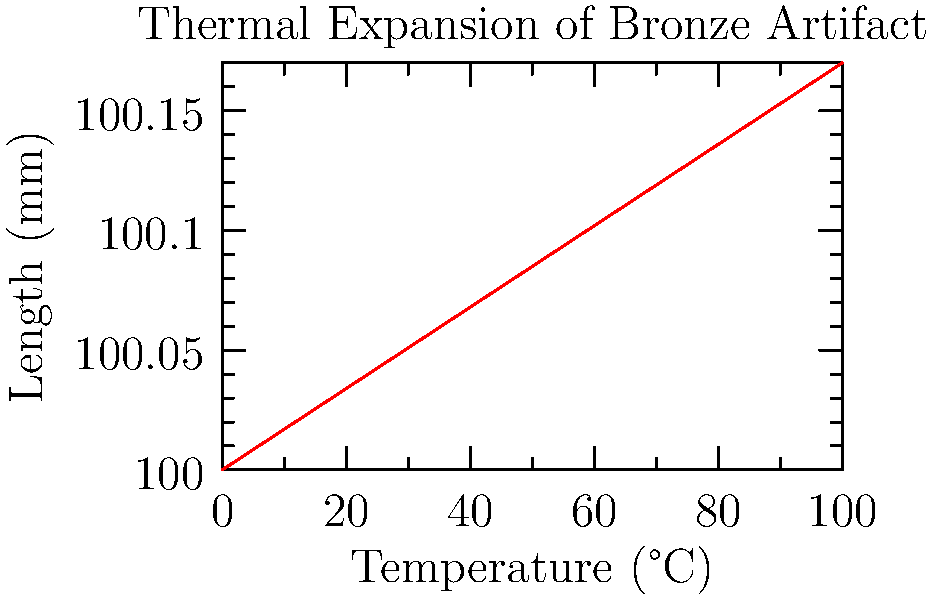A bronze artifact from an ancient civilization is being studied for its thermal expansion properties. The graph shows the length of the artifact as it is exposed to different temperatures. If the artifact's original length at 0°C is 100 mm, what is its coefficient of linear thermal expansion? To find the coefficient of linear thermal expansion (α), we'll use the formula:

$$ \Delta L = L_0 \alpha \Delta T $$

Where:
$\Delta L$ = Change in length
$L_0$ = Original length
$\alpha$ = Coefficient of linear thermal expansion
$\Delta T$ = Change in temperature

Steps:
1. Find $\Delta L$: At 100°C, L = 100.170 mm, so $\Delta L = 100.170 - 100.000 = 0.170$ mm

2. We know:
   $L_0 = 100$ mm
   $\Delta T = 100°C - 0°C = 100°C$

3. Substitute into the formula:
   $0.170 = 100 \cdot \alpha \cdot 100$

4. Solve for α:
   $\alpha = \frac{0.170}{100 \cdot 100} = 0.000017 /°C$

5. Convert to standard units:
   $\alpha = 17 \times 10^{-6} /°C$
Answer: $17 \times 10^{-6} /°C$ 